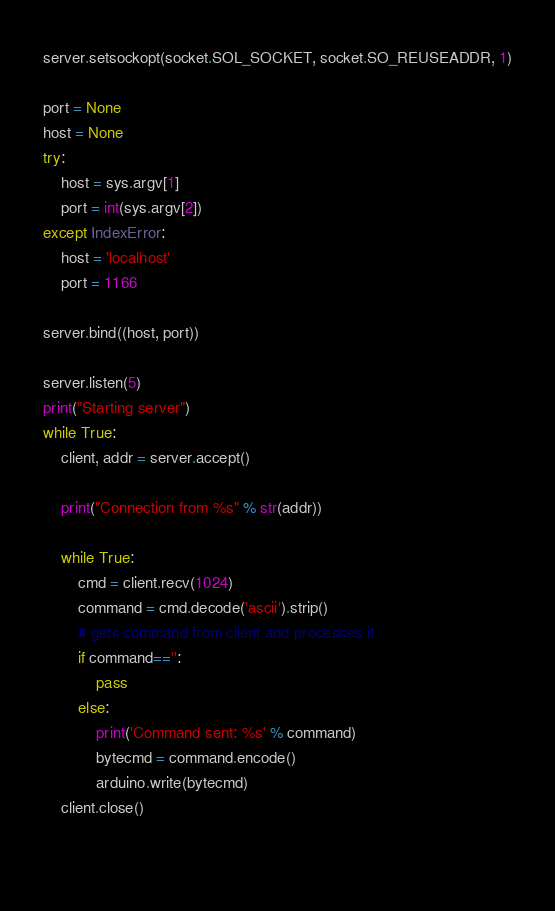<code> <loc_0><loc_0><loc_500><loc_500><_Python_>server.setsockopt(socket.SOL_SOCKET, socket.SO_REUSEADDR, 1)

port = None
host = None
try:
    host = sys.argv[1]
    port = int(sys.argv[2])
except IndexError:
    host = 'localhost'
    port = 1166

server.bind((host, port))

server.listen(5)
print("Starting server")
while True:
    client, addr = server.accept()

    print("Connection from %s" % str(addr))

    while True:
        cmd = client.recv(1024)
        command = cmd.decode('ascii').strip()
        # gets command from client and processes it
        if command=='':
            pass
        else:
            print('Command sent: %s' % command)
            bytecmd = command.encode()
            arduino.write(bytecmd)
    client.close()

        </code> 